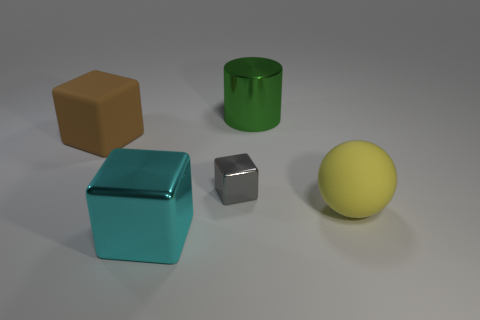Add 5 purple metal spheres. How many objects exist? 10 Subtract all cylinders. How many objects are left? 4 Add 5 small blue rubber balls. How many small blue rubber balls exist? 5 Subtract 0 yellow cylinders. How many objects are left? 5 Subtract all yellow spheres. Subtract all red metal balls. How many objects are left? 4 Add 5 large metallic cylinders. How many large metallic cylinders are left? 6 